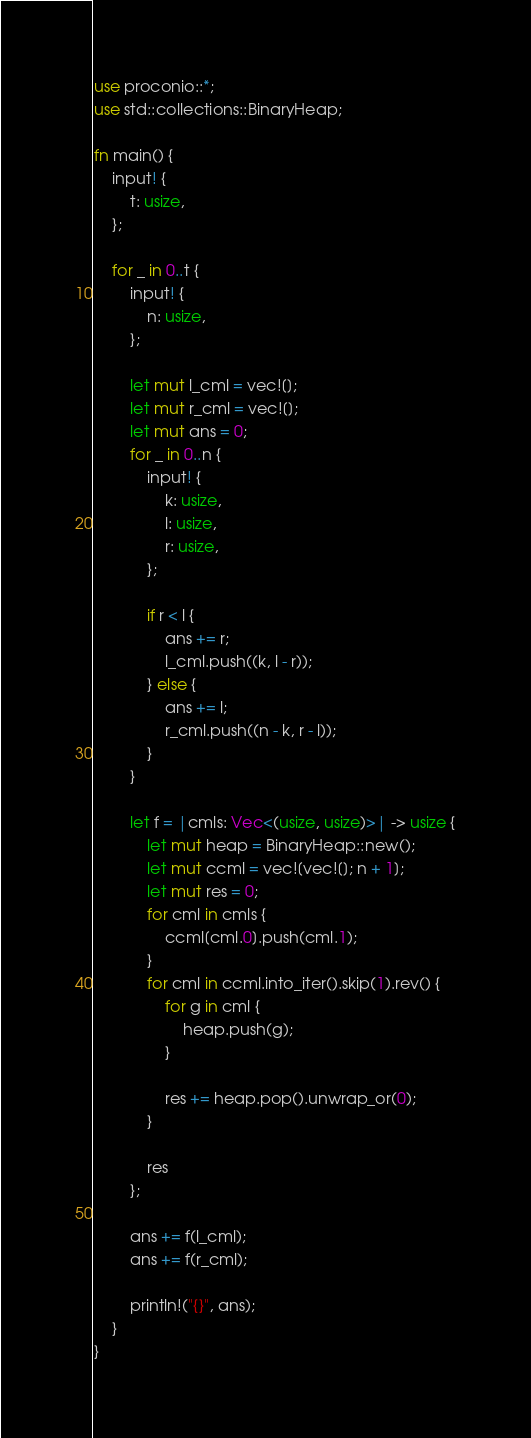Convert code to text. <code><loc_0><loc_0><loc_500><loc_500><_Rust_>use proconio::*;
use std::collections::BinaryHeap;

fn main() {
    input! {
        t: usize,
    };

    for _ in 0..t {
        input! {
            n: usize,
        };

        let mut l_cml = vec![];
        let mut r_cml = vec![];
        let mut ans = 0;
        for _ in 0..n {
            input! {
                k: usize,
                l: usize,
                r: usize,
            };

            if r < l {
                ans += r;
                l_cml.push((k, l - r));
            } else {
                ans += l;
                r_cml.push((n - k, r - l));
            }
        }

        let f = |cmls: Vec<(usize, usize)>| -> usize {
            let mut heap = BinaryHeap::new();
            let mut ccml = vec![vec![]; n + 1];
            let mut res = 0;
            for cml in cmls {
                ccml[cml.0].push(cml.1);
            }
            for cml in ccml.into_iter().skip(1).rev() {
                for g in cml {
                    heap.push(g);
                }

                res += heap.pop().unwrap_or(0);
            }

            res
        };

        ans += f(l_cml);
        ans += f(r_cml);

        println!("{}", ans);
    }
}
</code> 